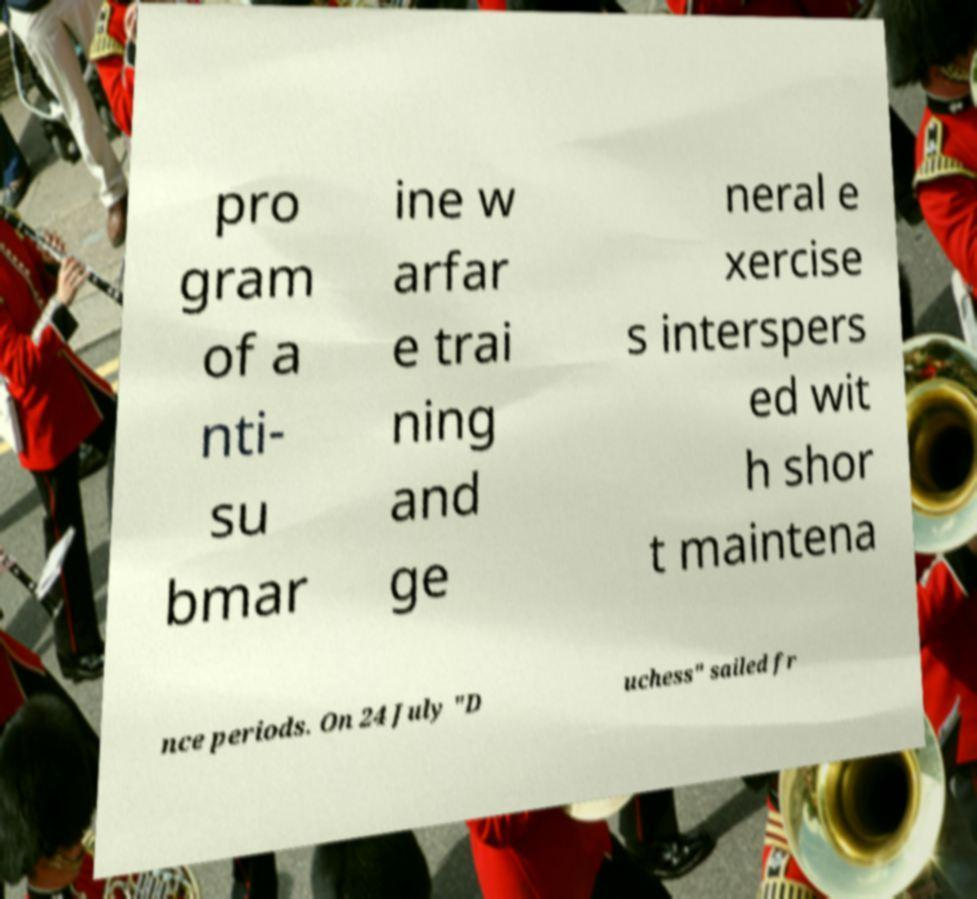There's text embedded in this image that I need extracted. Can you transcribe it verbatim? pro gram of a nti- su bmar ine w arfar e trai ning and ge neral e xercise s interspers ed wit h shor t maintena nce periods. On 24 July "D uchess" sailed fr 